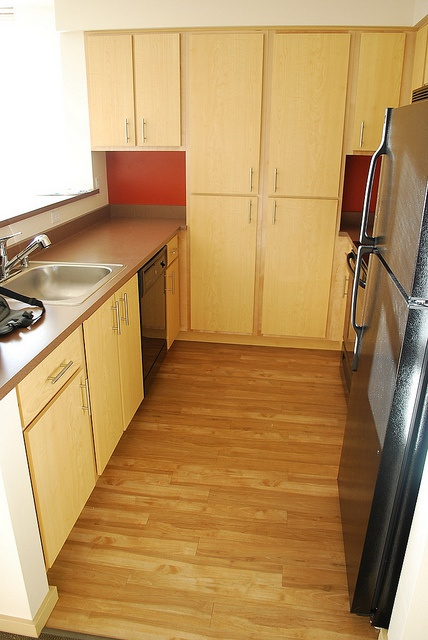Describe the objects in this image and their specific colors. I can see refrigerator in white, black, maroon, and gray tones, sink in white, tan, and gray tones, and oven in white, olive, maroon, and black tones in this image. 